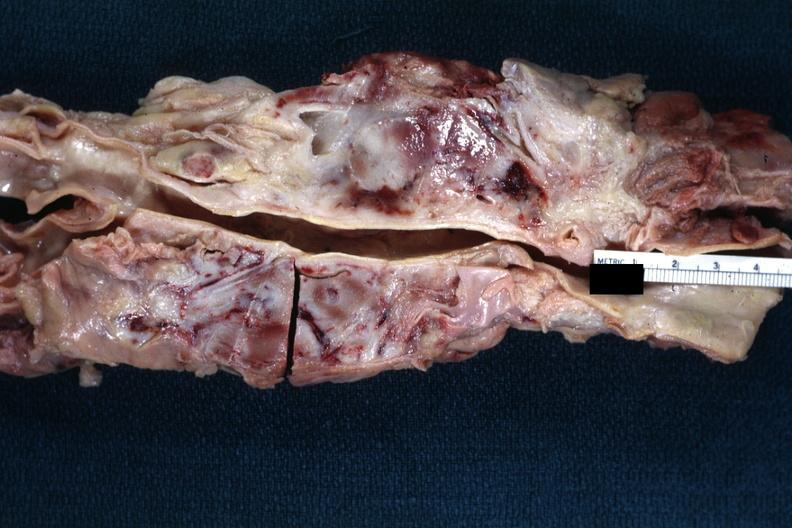s liver lesion present?
Answer the question using a single word or phrase. No 